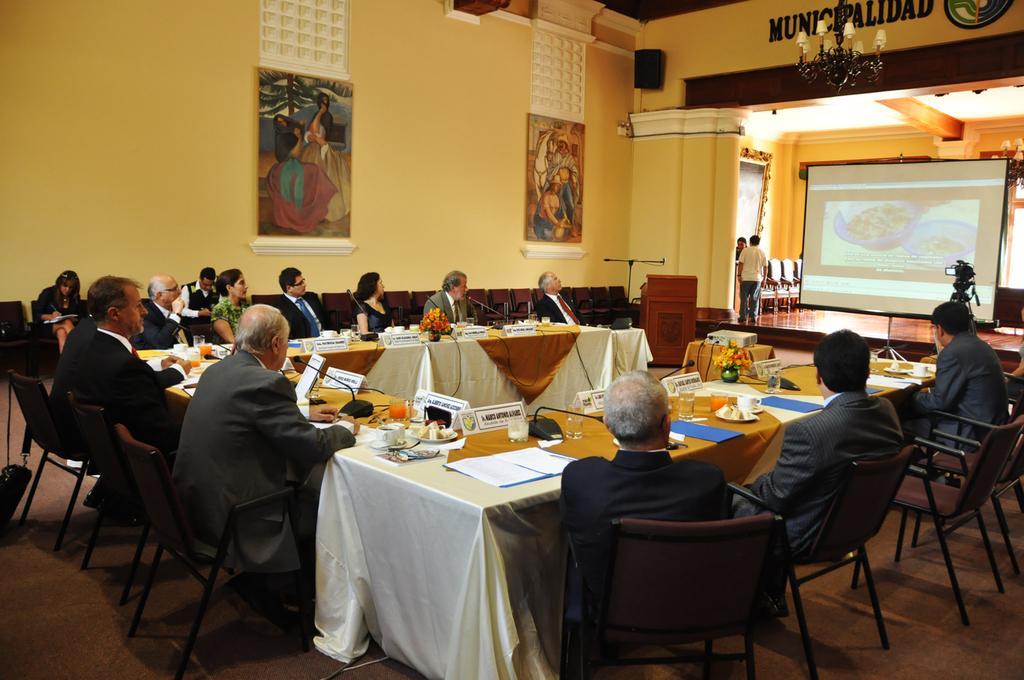In one or two sentences, can you explain what this image depicts? In this picture there are group of people sitting on the chair. There are two persons standing. There are two frames on the wall. There are nameplates, cup, glass , flowers and few objects on the table. 